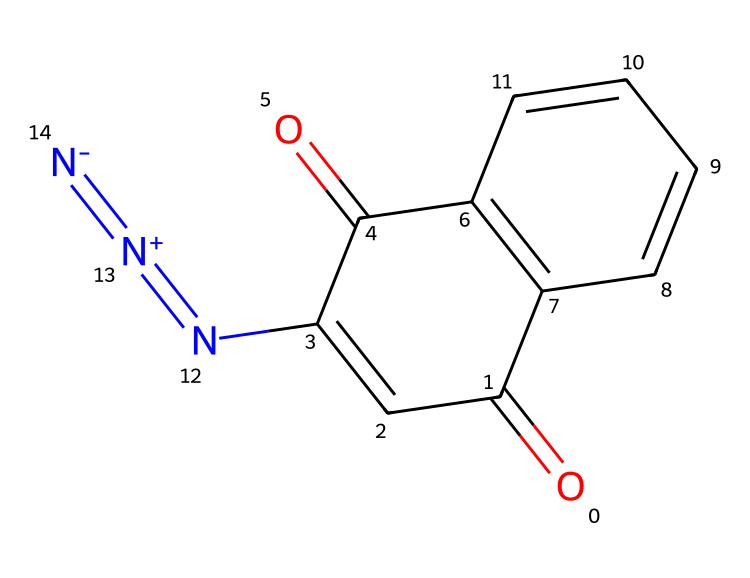How many nitrogen atoms are present in this chemical? By examining the SMILES representation, we can see there are two nitrogen atoms present in the structure. One of them is part of a diazonium group indicated by the [N+]=[N-] notation.
Answer: two What is the molecular formula of diazonaphthoquinone? To deduce the molecular formula, we count the atoms from the SMILES notation: 11 carbon atoms (C), 6 hydrogen atoms (H), 3 oxygen atoms (O), and 2 nitrogen atoms (N). This gives the molecular formula C11H6N2O3.
Answer: C11H6N2O3 What type of reaction does diazonaphthoquinone undergo upon exposure to light? Diazonaphthoquinone undergoes photolysis, a reaction where it breaks down upon absorbing light, leading to the formation of other chemical species that contribute to the photoresist properties.
Answer: photolysis How does the structure of DNQ contribute to its role in positive photoresists? The presence of functional groups like carbonyls (C=O) and the diazonium group enhances its capability to undergo changes upon exposure to light, which is critical to developing photoresist patterns in lithography.
Answer: enhances photoreactivity What is the significance of the conjugated double bonds in DNQ? The conjugated double bonds provide stability and affect the electronic properties of DNQ, which is important for its absorbance of light and subsequent reactivity in photoresist applications.
Answer: stability and reactivity How many rings are present in the DNQ structure? Upon inspection of the chemical structure, we can identify two fused ring systems in the molecule, indicating that there are two rings in total.
Answer: two 